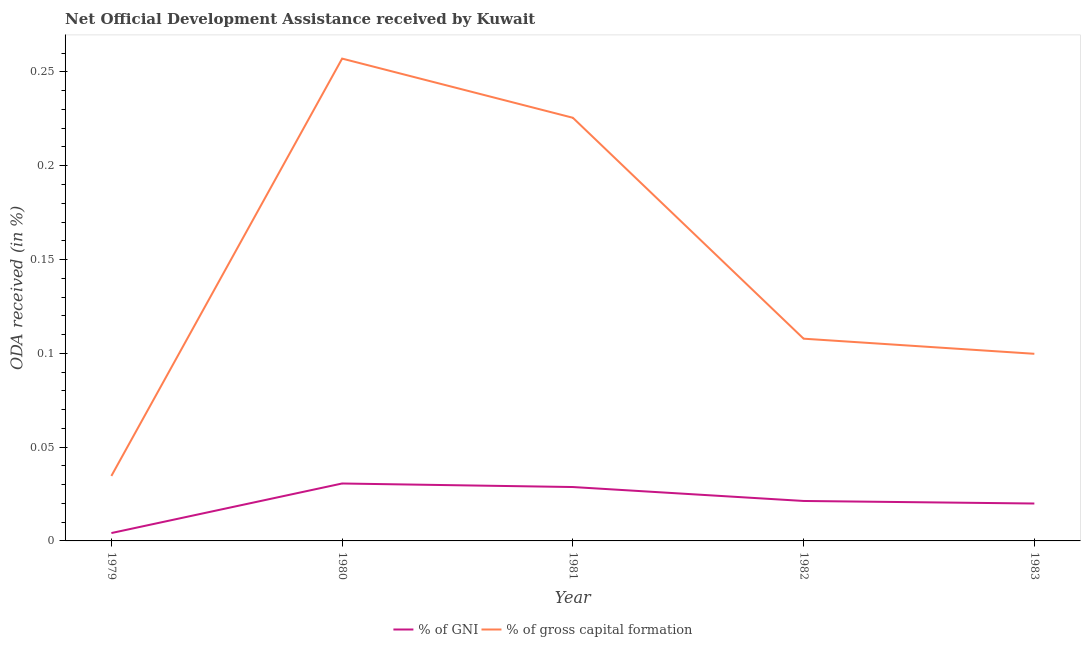What is the oda received as percentage of gni in 1982?
Offer a terse response. 0.02. Across all years, what is the maximum oda received as percentage of gross capital formation?
Give a very brief answer. 0.26. Across all years, what is the minimum oda received as percentage of gross capital formation?
Your answer should be very brief. 0.03. In which year was the oda received as percentage of gross capital formation minimum?
Give a very brief answer. 1979. What is the total oda received as percentage of gni in the graph?
Make the answer very short. 0.1. What is the difference between the oda received as percentage of gross capital formation in 1979 and that in 1980?
Keep it short and to the point. -0.22. What is the difference between the oda received as percentage of gross capital formation in 1981 and the oda received as percentage of gni in 1982?
Provide a short and direct response. 0.2. What is the average oda received as percentage of gni per year?
Provide a succinct answer. 0.02. In the year 1982, what is the difference between the oda received as percentage of gni and oda received as percentage of gross capital formation?
Give a very brief answer. -0.09. What is the ratio of the oda received as percentage of gni in 1980 to that in 1981?
Provide a short and direct response. 1.07. What is the difference between the highest and the second highest oda received as percentage of gross capital formation?
Keep it short and to the point. 0.03. What is the difference between the highest and the lowest oda received as percentage of gni?
Keep it short and to the point. 0.03. In how many years, is the oda received as percentage of gni greater than the average oda received as percentage of gni taken over all years?
Provide a succinct answer. 3. Does the oda received as percentage of gross capital formation monotonically increase over the years?
Your response must be concise. No. Is the oda received as percentage of gross capital formation strictly greater than the oda received as percentage of gni over the years?
Make the answer very short. Yes. Is the oda received as percentage of gross capital formation strictly less than the oda received as percentage of gni over the years?
Ensure brevity in your answer.  No. How many lines are there?
Keep it short and to the point. 2. What is the difference between two consecutive major ticks on the Y-axis?
Your answer should be compact. 0.05. What is the title of the graph?
Your answer should be very brief. Net Official Development Assistance received by Kuwait. What is the label or title of the Y-axis?
Give a very brief answer. ODA received (in %). What is the ODA received (in %) in % of GNI in 1979?
Give a very brief answer. 0. What is the ODA received (in %) in % of gross capital formation in 1979?
Provide a succinct answer. 0.03. What is the ODA received (in %) in % of GNI in 1980?
Your response must be concise. 0.03. What is the ODA received (in %) of % of gross capital formation in 1980?
Provide a succinct answer. 0.26. What is the ODA received (in %) in % of GNI in 1981?
Offer a very short reply. 0.03. What is the ODA received (in %) in % of gross capital formation in 1981?
Keep it short and to the point. 0.23. What is the ODA received (in %) in % of GNI in 1982?
Provide a succinct answer. 0.02. What is the ODA received (in %) in % of gross capital formation in 1982?
Offer a terse response. 0.11. What is the ODA received (in %) of % of GNI in 1983?
Ensure brevity in your answer.  0.02. What is the ODA received (in %) in % of gross capital formation in 1983?
Your response must be concise. 0.1. Across all years, what is the maximum ODA received (in %) of % of GNI?
Provide a succinct answer. 0.03. Across all years, what is the maximum ODA received (in %) in % of gross capital formation?
Offer a very short reply. 0.26. Across all years, what is the minimum ODA received (in %) in % of GNI?
Your answer should be compact. 0. Across all years, what is the minimum ODA received (in %) of % of gross capital formation?
Your response must be concise. 0.03. What is the total ODA received (in %) of % of GNI in the graph?
Offer a very short reply. 0.1. What is the total ODA received (in %) in % of gross capital formation in the graph?
Offer a very short reply. 0.72. What is the difference between the ODA received (in %) of % of GNI in 1979 and that in 1980?
Provide a succinct answer. -0.03. What is the difference between the ODA received (in %) of % of gross capital formation in 1979 and that in 1980?
Provide a succinct answer. -0.22. What is the difference between the ODA received (in %) in % of GNI in 1979 and that in 1981?
Your answer should be very brief. -0.02. What is the difference between the ODA received (in %) in % of gross capital formation in 1979 and that in 1981?
Keep it short and to the point. -0.19. What is the difference between the ODA received (in %) of % of GNI in 1979 and that in 1982?
Your response must be concise. -0.02. What is the difference between the ODA received (in %) of % of gross capital formation in 1979 and that in 1982?
Your answer should be compact. -0.07. What is the difference between the ODA received (in %) in % of GNI in 1979 and that in 1983?
Offer a very short reply. -0.02. What is the difference between the ODA received (in %) of % of gross capital formation in 1979 and that in 1983?
Offer a very short reply. -0.07. What is the difference between the ODA received (in %) of % of GNI in 1980 and that in 1981?
Your response must be concise. 0. What is the difference between the ODA received (in %) in % of gross capital formation in 1980 and that in 1981?
Your answer should be very brief. 0.03. What is the difference between the ODA received (in %) in % of GNI in 1980 and that in 1982?
Your response must be concise. 0.01. What is the difference between the ODA received (in %) in % of gross capital formation in 1980 and that in 1982?
Offer a very short reply. 0.15. What is the difference between the ODA received (in %) of % of GNI in 1980 and that in 1983?
Your response must be concise. 0.01. What is the difference between the ODA received (in %) of % of gross capital formation in 1980 and that in 1983?
Give a very brief answer. 0.16. What is the difference between the ODA received (in %) in % of GNI in 1981 and that in 1982?
Your answer should be compact. 0.01. What is the difference between the ODA received (in %) in % of gross capital formation in 1981 and that in 1982?
Offer a terse response. 0.12. What is the difference between the ODA received (in %) of % of GNI in 1981 and that in 1983?
Offer a terse response. 0.01. What is the difference between the ODA received (in %) in % of gross capital formation in 1981 and that in 1983?
Offer a terse response. 0.13. What is the difference between the ODA received (in %) of % of GNI in 1982 and that in 1983?
Make the answer very short. 0. What is the difference between the ODA received (in %) in % of gross capital formation in 1982 and that in 1983?
Your answer should be very brief. 0.01. What is the difference between the ODA received (in %) of % of GNI in 1979 and the ODA received (in %) of % of gross capital formation in 1980?
Ensure brevity in your answer.  -0.25. What is the difference between the ODA received (in %) of % of GNI in 1979 and the ODA received (in %) of % of gross capital formation in 1981?
Provide a short and direct response. -0.22. What is the difference between the ODA received (in %) in % of GNI in 1979 and the ODA received (in %) in % of gross capital formation in 1982?
Offer a terse response. -0.1. What is the difference between the ODA received (in %) in % of GNI in 1979 and the ODA received (in %) in % of gross capital formation in 1983?
Your answer should be very brief. -0.1. What is the difference between the ODA received (in %) in % of GNI in 1980 and the ODA received (in %) in % of gross capital formation in 1981?
Keep it short and to the point. -0.2. What is the difference between the ODA received (in %) in % of GNI in 1980 and the ODA received (in %) in % of gross capital formation in 1982?
Give a very brief answer. -0.08. What is the difference between the ODA received (in %) of % of GNI in 1980 and the ODA received (in %) of % of gross capital formation in 1983?
Make the answer very short. -0.07. What is the difference between the ODA received (in %) in % of GNI in 1981 and the ODA received (in %) in % of gross capital formation in 1982?
Make the answer very short. -0.08. What is the difference between the ODA received (in %) in % of GNI in 1981 and the ODA received (in %) in % of gross capital formation in 1983?
Provide a succinct answer. -0.07. What is the difference between the ODA received (in %) of % of GNI in 1982 and the ODA received (in %) of % of gross capital formation in 1983?
Provide a succinct answer. -0.08. What is the average ODA received (in %) of % of GNI per year?
Provide a succinct answer. 0.02. What is the average ODA received (in %) of % of gross capital formation per year?
Provide a succinct answer. 0.14. In the year 1979, what is the difference between the ODA received (in %) of % of GNI and ODA received (in %) of % of gross capital formation?
Your response must be concise. -0.03. In the year 1980, what is the difference between the ODA received (in %) of % of GNI and ODA received (in %) of % of gross capital formation?
Offer a terse response. -0.23. In the year 1981, what is the difference between the ODA received (in %) of % of GNI and ODA received (in %) of % of gross capital formation?
Give a very brief answer. -0.2. In the year 1982, what is the difference between the ODA received (in %) of % of GNI and ODA received (in %) of % of gross capital formation?
Ensure brevity in your answer.  -0.09. In the year 1983, what is the difference between the ODA received (in %) of % of GNI and ODA received (in %) of % of gross capital formation?
Make the answer very short. -0.08. What is the ratio of the ODA received (in %) of % of GNI in 1979 to that in 1980?
Offer a terse response. 0.14. What is the ratio of the ODA received (in %) of % of gross capital formation in 1979 to that in 1980?
Give a very brief answer. 0.13. What is the ratio of the ODA received (in %) of % of GNI in 1979 to that in 1981?
Offer a very short reply. 0.15. What is the ratio of the ODA received (in %) of % of gross capital formation in 1979 to that in 1981?
Offer a very short reply. 0.15. What is the ratio of the ODA received (in %) of % of GNI in 1979 to that in 1982?
Keep it short and to the point. 0.2. What is the ratio of the ODA received (in %) of % of gross capital formation in 1979 to that in 1982?
Offer a very short reply. 0.32. What is the ratio of the ODA received (in %) of % of GNI in 1979 to that in 1983?
Your answer should be compact. 0.21. What is the ratio of the ODA received (in %) in % of gross capital formation in 1979 to that in 1983?
Give a very brief answer. 0.35. What is the ratio of the ODA received (in %) in % of GNI in 1980 to that in 1981?
Your answer should be very brief. 1.07. What is the ratio of the ODA received (in %) in % of gross capital formation in 1980 to that in 1981?
Offer a terse response. 1.14. What is the ratio of the ODA received (in %) of % of GNI in 1980 to that in 1982?
Keep it short and to the point. 1.44. What is the ratio of the ODA received (in %) in % of gross capital formation in 1980 to that in 1982?
Your answer should be compact. 2.38. What is the ratio of the ODA received (in %) in % of GNI in 1980 to that in 1983?
Provide a succinct answer. 1.53. What is the ratio of the ODA received (in %) in % of gross capital formation in 1980 to that in 1983?
Provide a succinct answer. 2.58. What is the ratio of the ODA received (in %) in % of GNI in 1981 to that in 1982?
Ensure brevity in your answer.  1.35. What is the ratio of the ODA received (in %) in % of gross capital formation in 1981 to that in 1982?
Offer a very short reply. 2.09. What is the ratio of the ODA received (in %) of % of GNI in 1981 to that in 1983?
Keep it short and to the point. 1.44. What is the ratio of the ODA received (in %) in % of gross capital formation in 1981 to that in 1983?
Ensure brevity in your answer.  2.26. What is the ratio of the ODA received (in %) in % of GNI in 1982 to that in 1983?
Your answer should be compact. 1.07. What is the ratio of the ODA received (in %) of % of gross capital formation in 1982 to that in 1983?
Make the answer very short. 1.08. What is the difference between the highest and the second highest ODA received (in %) of % of GNI?
Keep it short and to the point. 0. What is the difference between the highest and the second highest ODA received (in %) in % of gross capital formation?
Give a very brief answer. 0.03. What is the difference between the highest and the lowest ODA received (in %) of % of GNI?
Offer a very short reply. 0.03. What is the difference between the highest and the lowest ODA received (in %) in % of gross capital formation?
Provide a succinct answer. 0.22. 